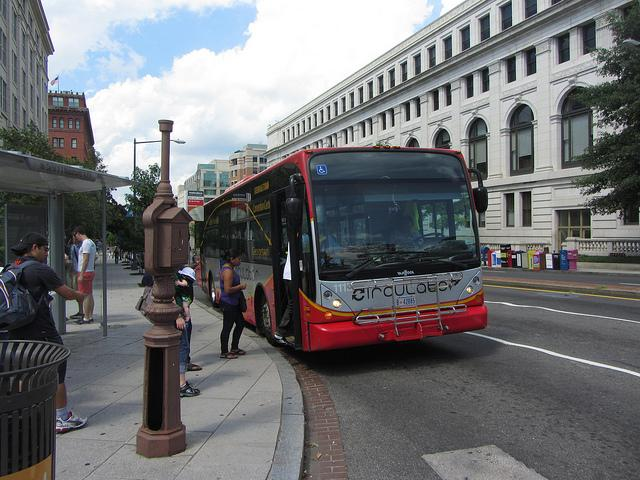What special group of people are accommodated in the bus?

Choices:
A) pregnant women
B) blind
C) handicapped
D) elderly handicapped 